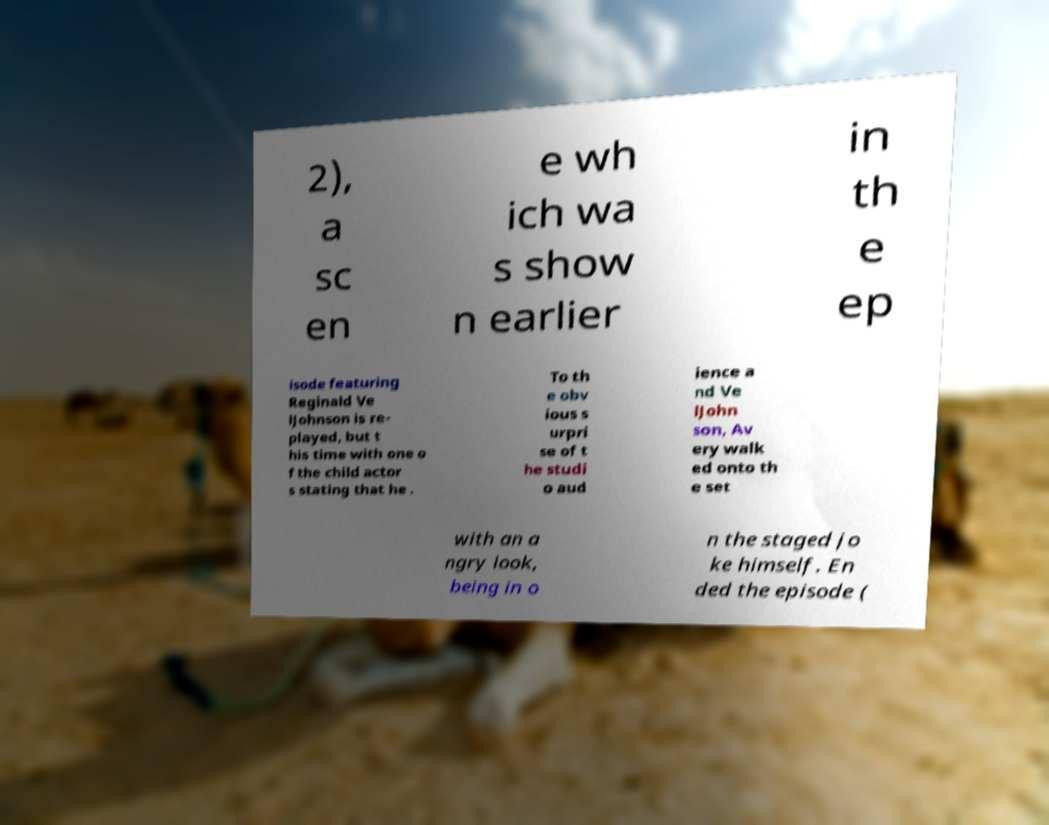What messages or text are displayed in this image? I need them in a readable, typed format. 2), a sc en e wh ich wa s show n earlier in th e ep isode featuring Reginald Ve lJohnson is re- played, but t his time with one o f the child actor s stating that he . To th e obv ious s urpri se of t he studi o aud ience a nd Ve lJohn son, Av ery walk ed onto th e set with an a ngry look, being in o n the staged jo ke himself. En ded the episode ( 